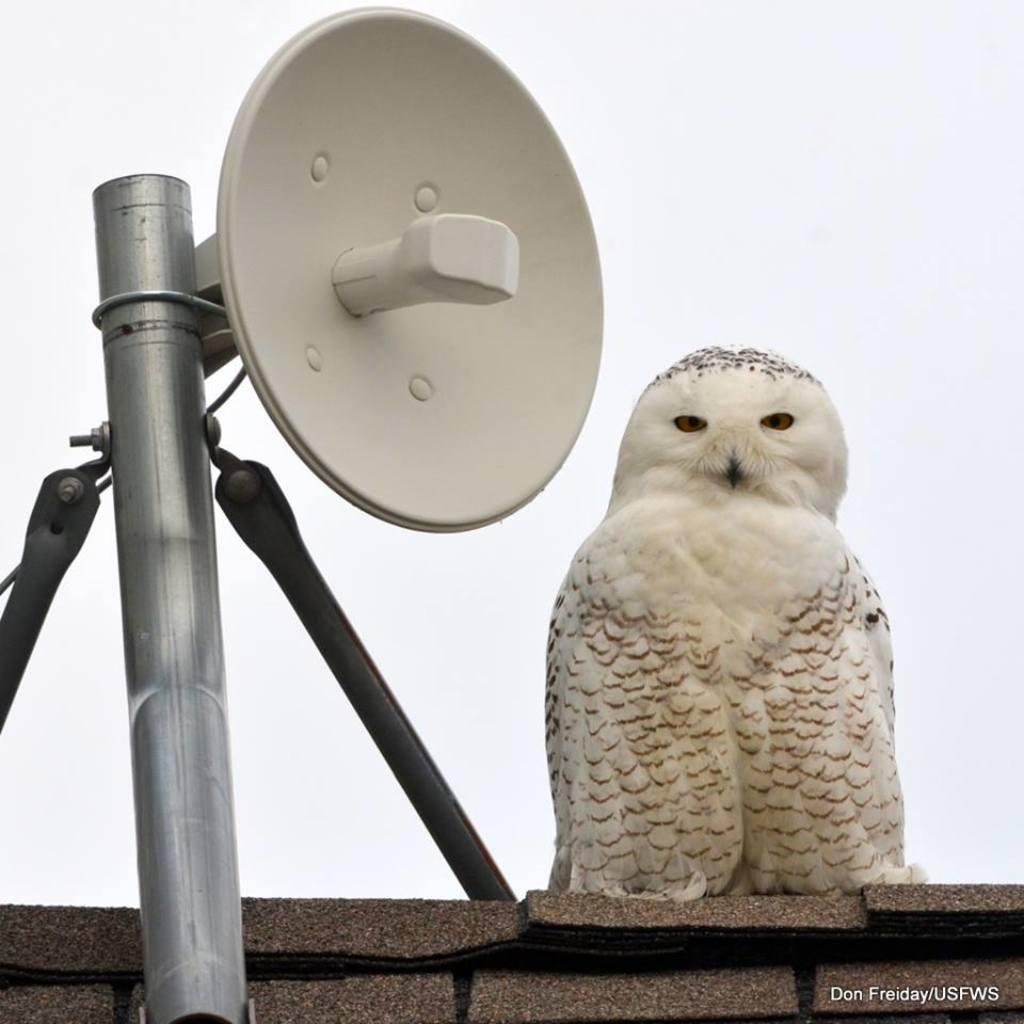What animal is in the center of the image? There is an owl in the center of the image. What is located on the left side of the image? There is an iron rod on the left side of the image. What is associated with the iron rod? There is an object associated with the iron rod. What type of structure is at the bottom of the image? There is a wall at the bottom of the image. What type of plants can be seen growing near the owl in the image? There are no plants visible in the image; it only features an owl, an iron rod, an associated object, and a wall. 